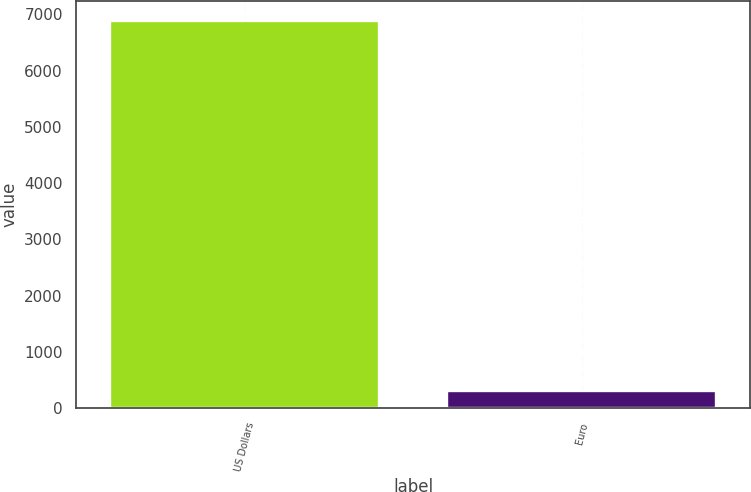Convert chart to OTSL. <chart><loc_0><loc_0><loc_500><loc_500><bar_chart><fcel>US Dollars<fcel>Euro<nl><fcel>6891<fcel>305<nl></chart> 